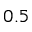<formula> <loc_0><loc_0><loc_500><loc_500>0 . 5</formula> 